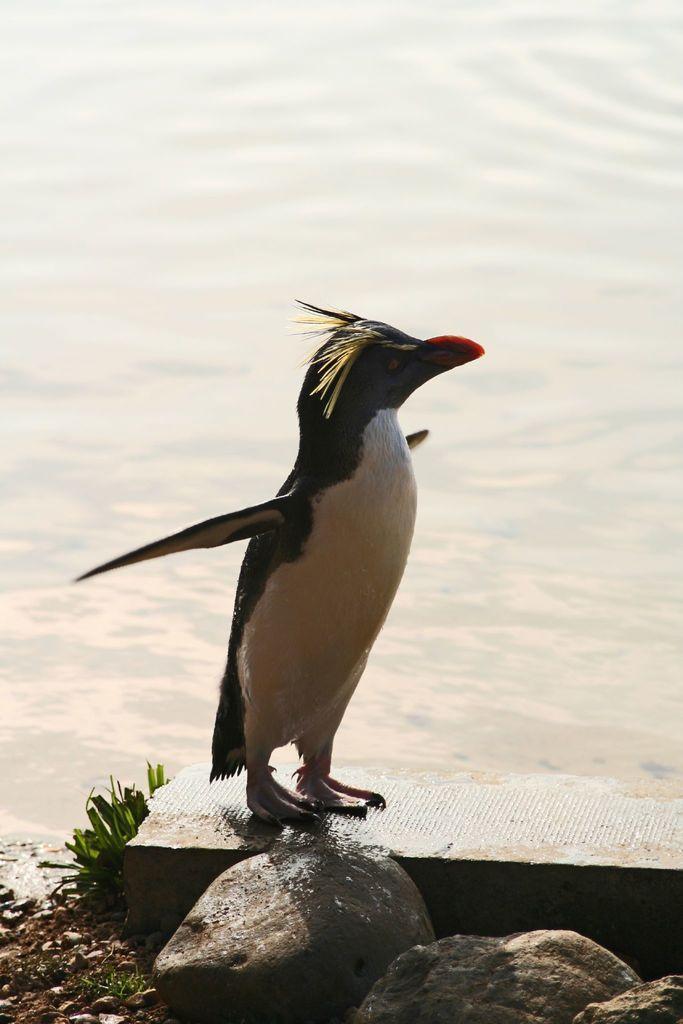Please provide a concise description of this image. In this image, we can see a penguin standing. We can also see some rocks. We can see the ground and some grass. We can see some water. 